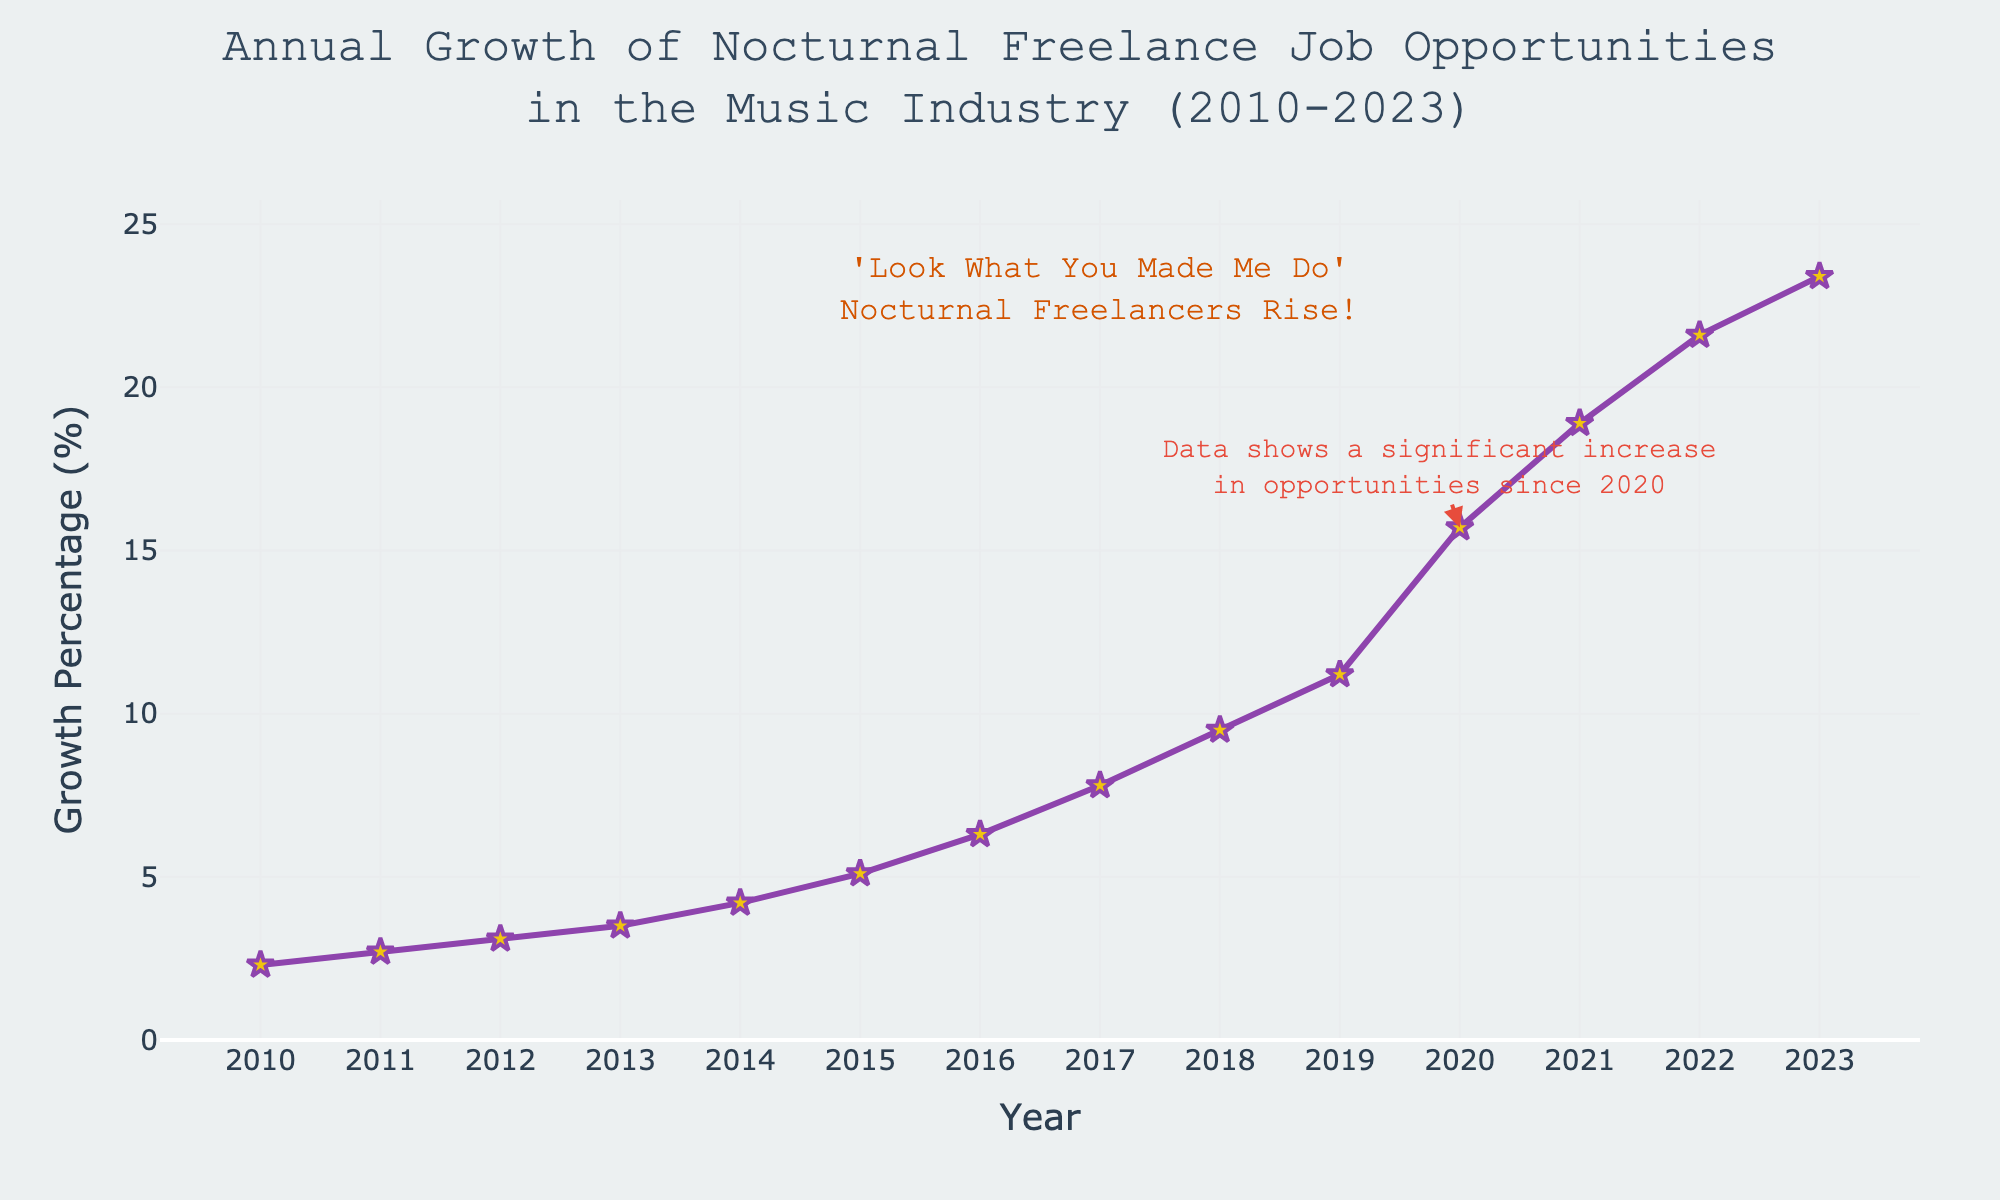What was the highest growth percentage recorded in the given years? The highest growth percentage can be found by looking at the highest data point on the y-axis, which is 23.4% in the year 2023.
Answer: 23.4% Between which years did the most significant increase in growth percentage occur? By examining the line chart, the steepest slope occurs between 2019 and 2020. The growth percentage jumps from 11.2% to 15.7%, indicating the most significant increase.
Answer: 2019 to 2020 What is the average growth percentage from 2010 to 2015? To find the average, add the growth percentages from 2010 to 2015 (2.3 + 2.7 + 3.1 + 3.5 + 4.2 + 5.1) and divide by the number of years (6). The sum is 20.9, so the average is 20.9 / 6 = 3.48.
Answer: 3.48 What is the visual difference between the markers on the line chart and the gridlines? The markers on the line chart are star-shaped, yellow with a purple outline, while the gridlines are light grey.
Answer: Star-shaped, yellow with purple outline for markers, light grey for gridlines How much did the growth percentage increase from 2017 to 2023? To find the increase, subtract the growth percentage in 2017 from the growth percentage in 2023. So, 23.4% - 7.8% = 15.6%.
Answer: 15.6% How does the growth percentage in 2012 compare to the growth percentage in 2014? The growth percentage in 2012 is 3.1% while in 2014 it is 4.2%. 4.2% is greater than 3.1%.
Answer: 2014 > 2012 What annotation is added to the year 2017? The annotation added to the year 2017 is a Taylor Swift-inspired note that reads "'Look What You Made Me Do' Nocturnal Freelancers Rise!"
Answer: 'Look What You Made Me Do' Nocturnal Freelancers Rise! What is the total growth percentage accumulated from 2010 to 2023? Add all the growth percentages from 2010 to 2023 (2.3 + 2.7 + 3.1 + 3.5 + 4.2 + 5.1 + 6.3 + 7.8 + 9.5 + 11.2 + 15.7 + 18.9 + 21.6 + 23.4). The sum is 135.3.
Answer: 135.3 Which year marks a significant rise in the annotations? The annotation indicating a significant increase is marked in 2020, where there is a steep increase in the growth percentage.
Answer: 2020 What does the annotation near the year 2020 imply? The annotation near the year 2020 suggests a significant increase in job opportunities, mentioning "Data shows a significant increase in opportunities since 2020."
Answer: Significant increase since 2020 